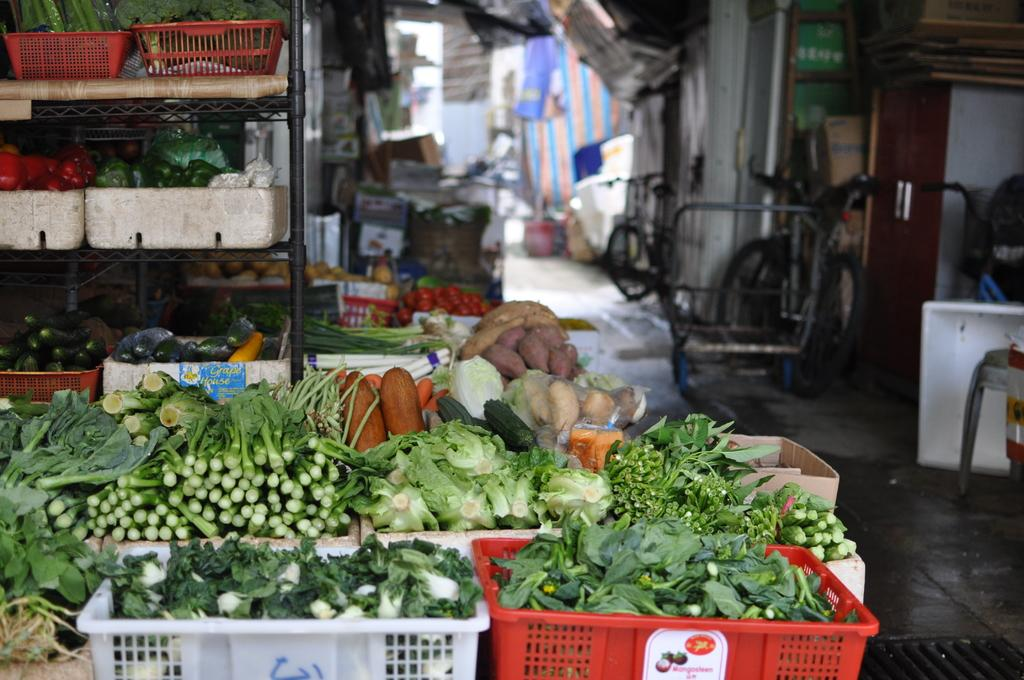What type of objects can be seen in the image? There are bicycles, blankets, cardboard cartons, and baskets of vegetables in the image. What might the blankets be used for? The blankets could be used for warmth or as a covering. What are the cardboard cartons likely used for? The cardboard cartons are likely used for storage or transportation. How are the vegetables arranged in the image? The vegetables are arranged in baskets in the image. What architectural feature is present in the image? There are doors in the image. What part of the image is visible beneath the objects? The floor is visible in the image. What type of baseball can be seen in the image? There is no baseball present in the image. What does the lip of the cardboard carton look like in the image? There is no lip visible on the cardboard cartons in the image. 